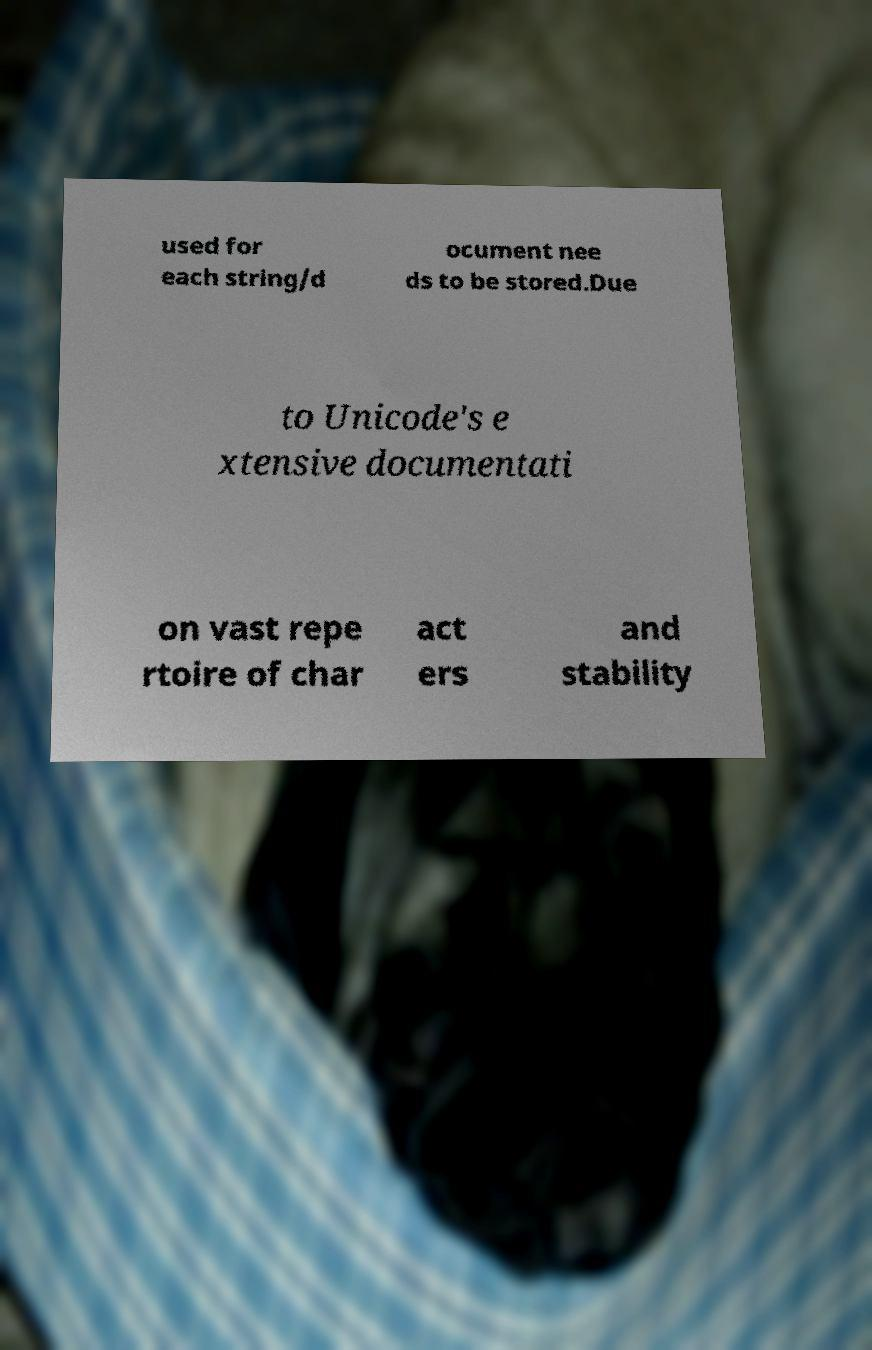What messages or text are displayed in this image? I need them in a readable, typed format. used for each string/d ocument nee ds to be stored.Due to Unicode's e xtensive documentati on vast repe rtoire of char act ers and stability 